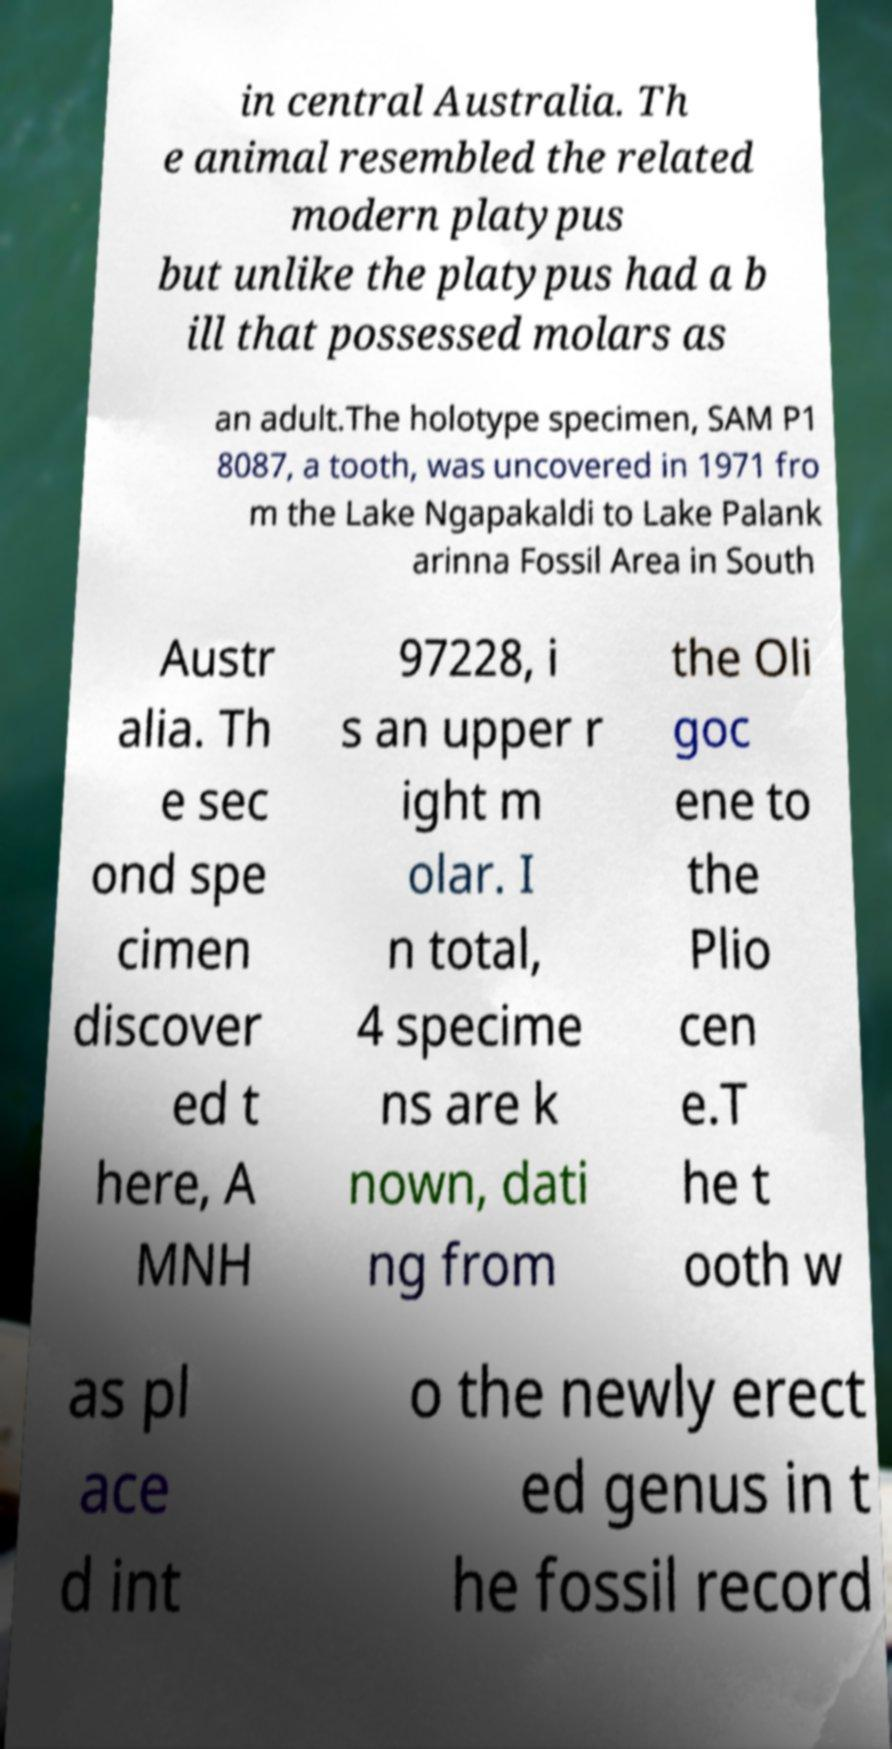Please identify and transcribe the text found in this image. in central Australia. Th e animal resembled the related modern platypus but unlike the platypus had a b ill that possessed molars as an adult.The holotype specimen, SAM P1 8087, a tooth, was uncovered in 1971 fro m the Lake Ngapakaldi to Lake Palank arinna Fossil Area in South Austr alia. Th e sec ond spe cimen discover ed t here, A MNH 97228, i s an upper r ight m olar. I n total, 4 specime ns are k nown, dati ng from the Oli goc ene to the Plio cen e.T he t ooth w as pl ace d int o the newly erect ed genus in t he fossil record 